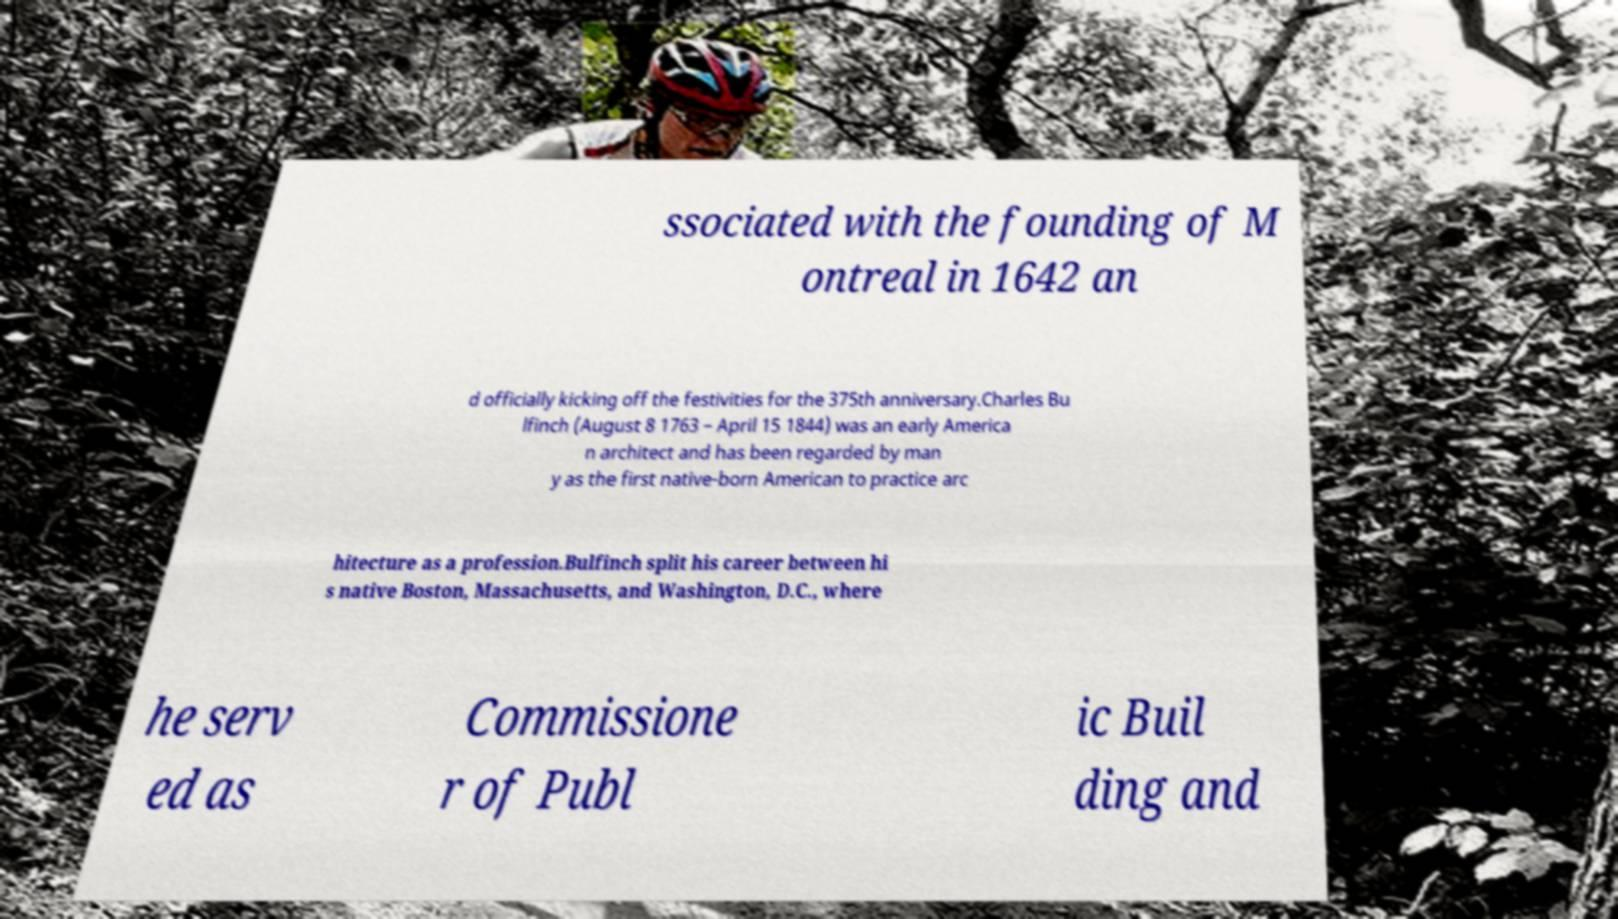There's text embedded in this image that I need extracted. Can you transcribe it verbatim? ssociated with the founding of M ontreal in 1642 an d officially kicking off the festivities for the 375th anniversary.Charles Bu lfinch (August 8 1763 – April 15 1844) was an early America n architect and has been regarded by man y as the first native-born American to practice arc hitecture as a profession.Bulfinch split his career between hi s native Boston, Massachusetts, and Washington, D.C., where he serv ed as Commissione r of Publ ic Buil ding and 